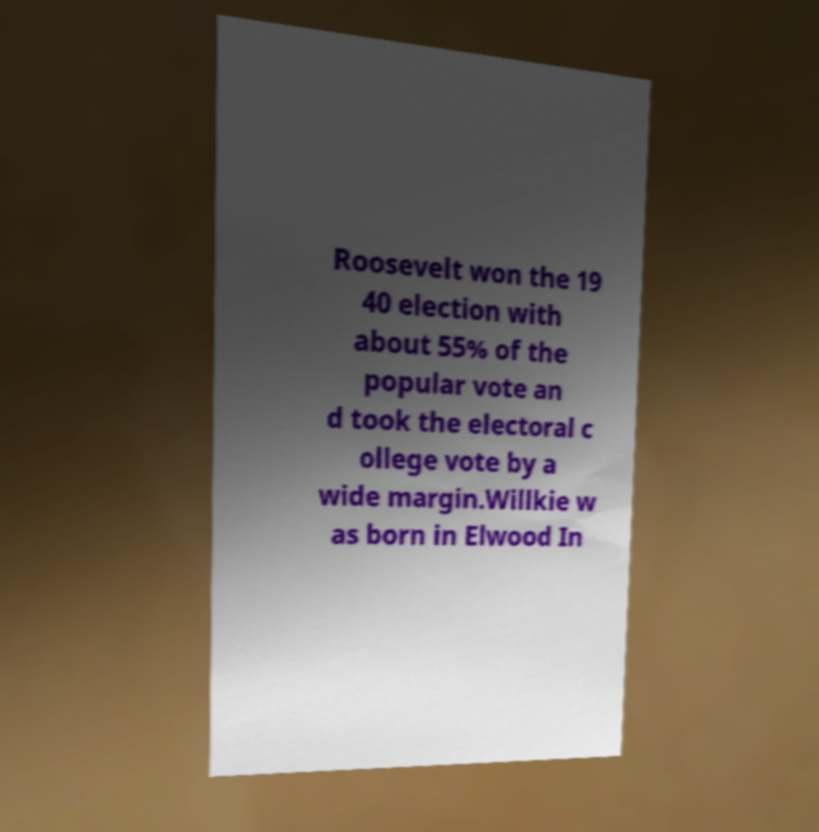Please read and relay the text visible in this image. What does it say? Roosevelt won the 19 40 election with about 55% of the popular vote an d took the electoral c ollege vote by a wide margin.Willkie w as born in Elwood In 